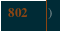Convert code to text. <code><loc_0><loc_0><loc_500><loc_500><_Kotlin_>)

</code> 